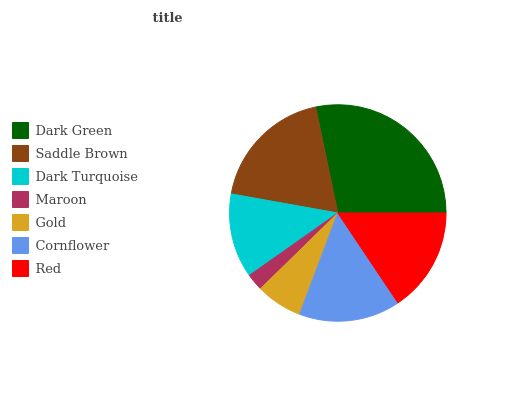Is Maroon the minimum?
Answer yes or no. Yes. Is Dark Green the maximum?
Answer yes or no. Yes. Is Saddle Brown the minimum?
Answer yes or no. No. Is Saddle Brown the maximum?
Answer yes or no. No. Is Dark Green greater than Saddle Brown?
Answer yes or no. Yes. Is Saddle Brown less than Dark Green?
Answer yes or no. Yes. Is Saddle Brown greater than Dark Green?
Answer yes or no. No. Is Dark Green less than Saddle Brown?
Answer yes or no. No. Is Cornflower the high median?
Answer yes or no. Yes. Is Cornflower the low median?
Answer yes or no. Yes. Is Saddle Brown the high median?
Answer yes or no. No. Is Maroon the low median?
Answer yes or no. No. 